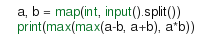Convert code to text. <code><loc_0><loc_0><loc_500><loc_500><_Python_>a, b = map(int, input().split())
print(max(max(a-b, a+b), a*b))</code> 